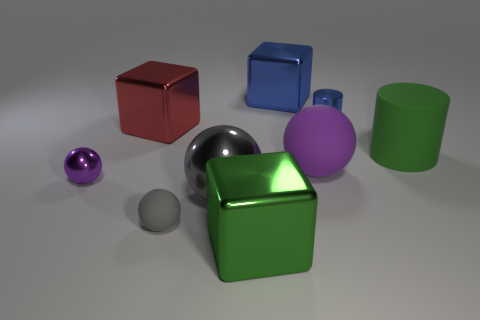There is a sphere that is left of the big gray thing and behind the small gray object; what size is it?
Your response must be concise. Small. What number of other things are there of the same material as the tiny gray ball
Your answer should be compact. 2. How big is the gray thing that is in front of the large gray metal sphere?
Your answer should be compact. Small. Is the color of the tiny rubber sphere the same as the big metal ball?
Offer a very short reply. Yes. What number of tiny objects are either gray balls or green cylinders?
Give a very brief answer. 1. There is a big purple rubber thing; are there any metal cylinders behind it?
Provide a succinct answer. Yes. There is a purple object in front of the big rubber object that is on the left side of the big matte cylinder; how big is it?
Offer a terse response. Small. Are there an equal number of purple things to the right of the red thing and blue blocks that are in front of the big green rubber cylinder?
Offer a terse response. No. There is a small object that is on the right side of the large blue shiny object; is there a blue thing on the right side of it?
Provide a short and direct response. No. What number of gray rubber things are behind the small object behind the purple ball on the right side of the red block?
Offer a very short reply. 0. 